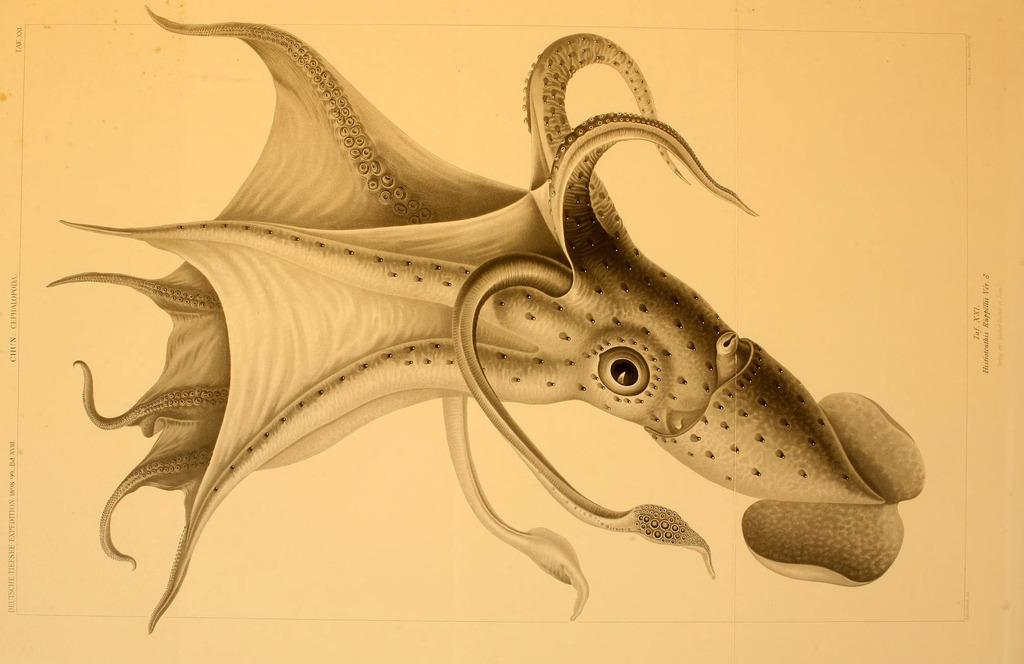What is the main subject of the image? There is a picture of an octopus in the image. Who is offering the parcel to the octopus in the image? There is no parcel or person offering it in the image; it only features a picture of an octopus. 